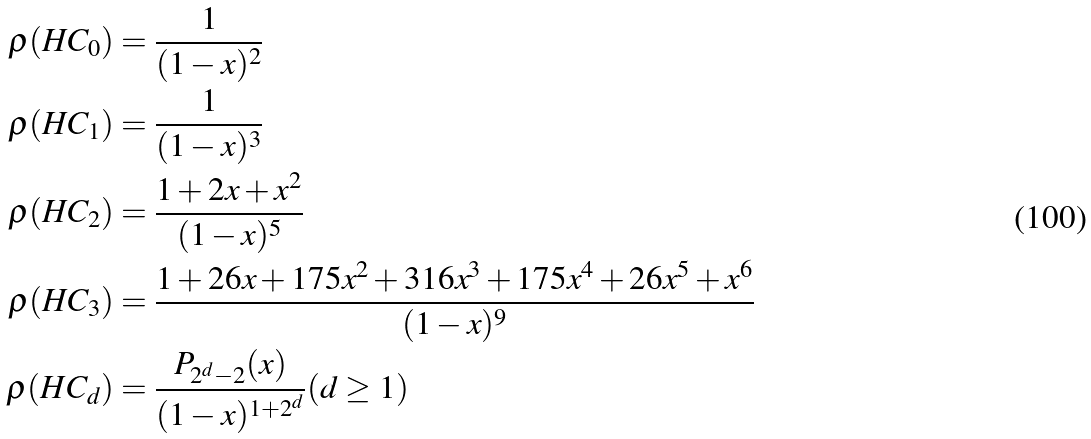Convert formula to latex. <formula><loc_0><loc_0><loc_500><loc_500>\rho ( H C _ { 0 } ) & = \frac { 1 } { ( 1 - x ) ^ { 2 } } \\ \rho ( H C _ { 1 } ) & = \frac { 1 } { ( 1 - x ) ^ { 3 } } \\ \rho ( H C _ { 2 } ) & = \frac { 1 + 2 x + x ^ { 2 } } { ( 1 - x ) ^ { 5 } } \\ \rho ( H C _ { 3 } ) & = \frac { 1 + 2 6 x + 1 7 5 x ^ { 2 } + 3 1 6 x ^ { 3 } + 1 7 5 x ^ { 4 } + 2 6 x ^ { 5 } + x ^ { 6 } } { ( 1 - x ) ^ { 9 } } \\ \rho ( H C _ { d } ) & = \frac { P _ { 2 ^ { d } - 2 } ( x ) } { ( 1 - x ) ^ { 1 + 2 ^ { d } } } ( d \geq 1 )</formula> 